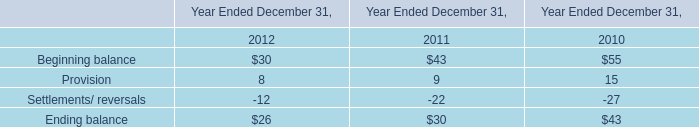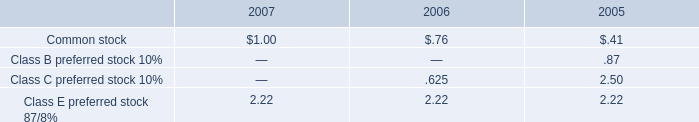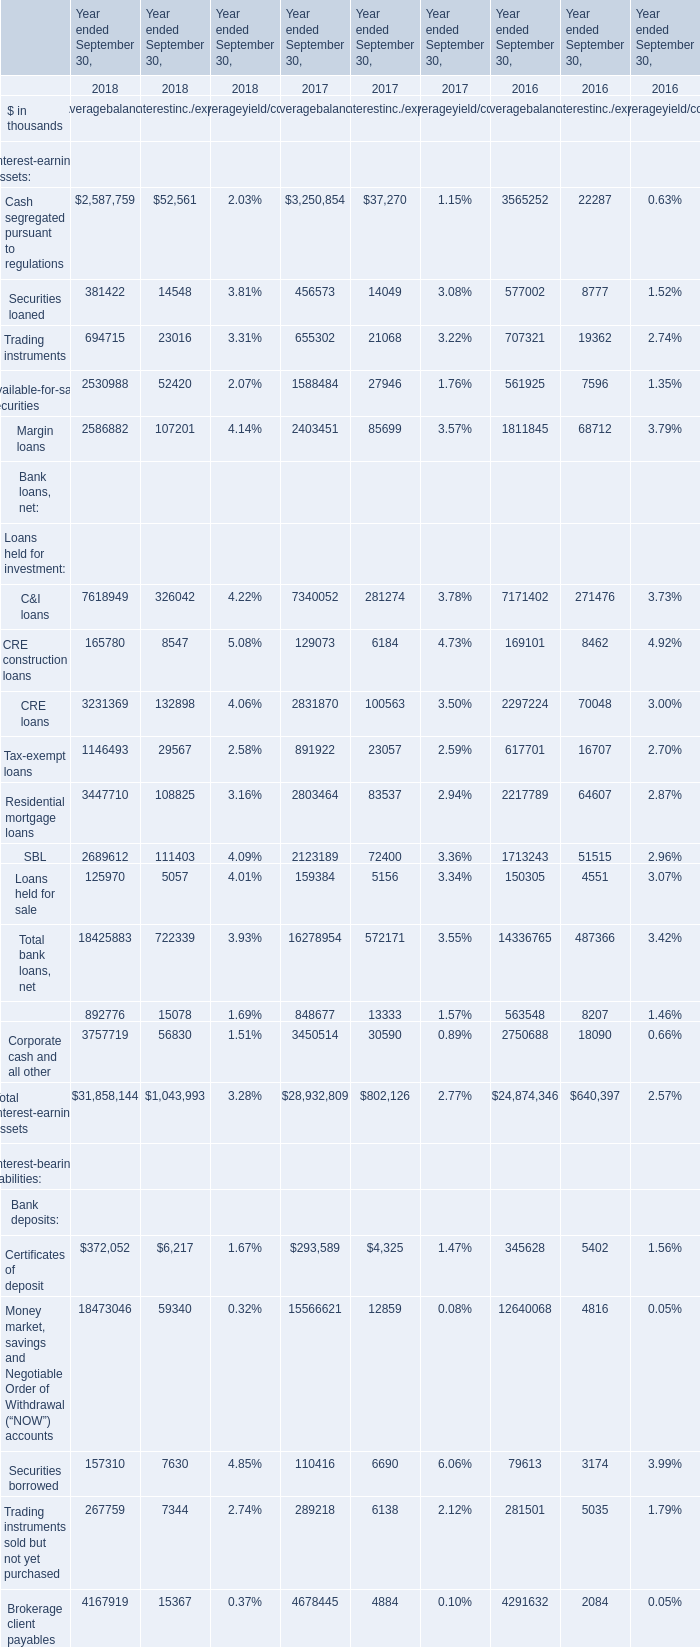Which Year ended September 30 is the value of the Average balance for the Total interest-earning assets the highest? 
Answer: 2018. 